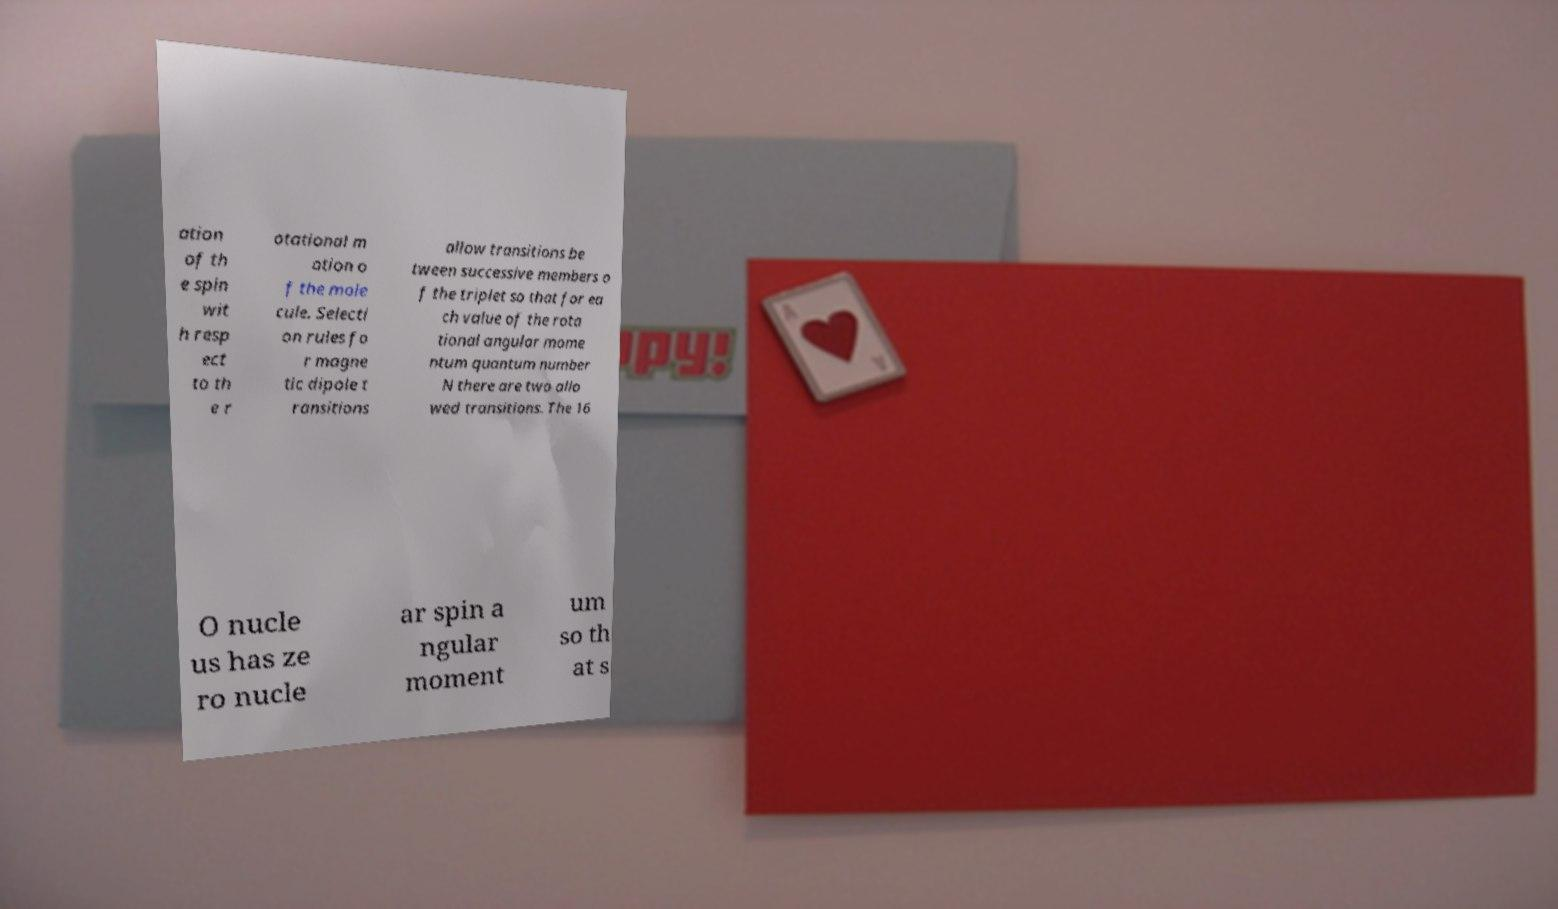Can you accurately transcribe the text from the provided image for me? ation of th e spin wit h resp ect to th e r otational m otion o f the mole cule. Selecti on rules fo r magne tic dipole t ransitions allow transitions be tween successive members o f the triplet so that for ea ch value of the rota tional angular mome ntum quantum number N there are two allo wed transitions. The 16 O nucle us has ze ro nucle ar spin a ngular moment um so th at s 